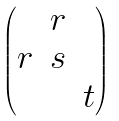Convert formula to latex. <formula><loc_0><loc_0><loc_500><loc_500>\begin{pmatrix} & r & \\ r & s & \\ & & t \end{pmatrix}</formula> 